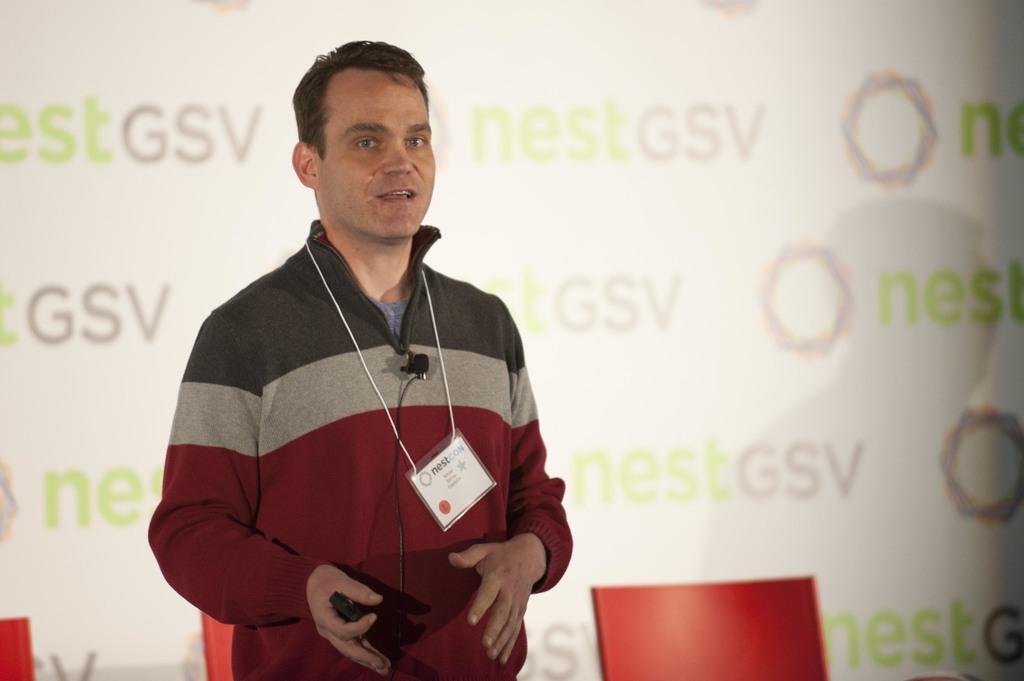Please provide a concise description of this image. In this image I can see a person wearing maroon, ash and black colored dress is standing and holding a black colored object in his hand. In the background I can see the white colored banner. 